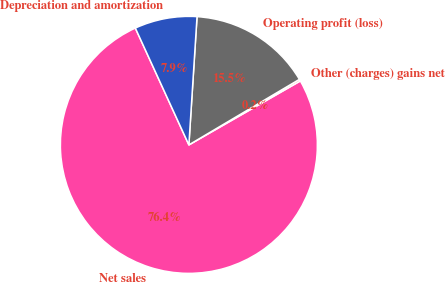<chart> <loc_0><loc_0><loc_500><loc_500><pie_chart><fcel>Net sales<fcel>Other (charges) gains net<fcel>Operating profit (loss)<fcel>Depreciation and amortization<nl><fcel>76.44%<fcel>0.23%<fcel>15.47%<fcel>7.85%<nl></chart> 